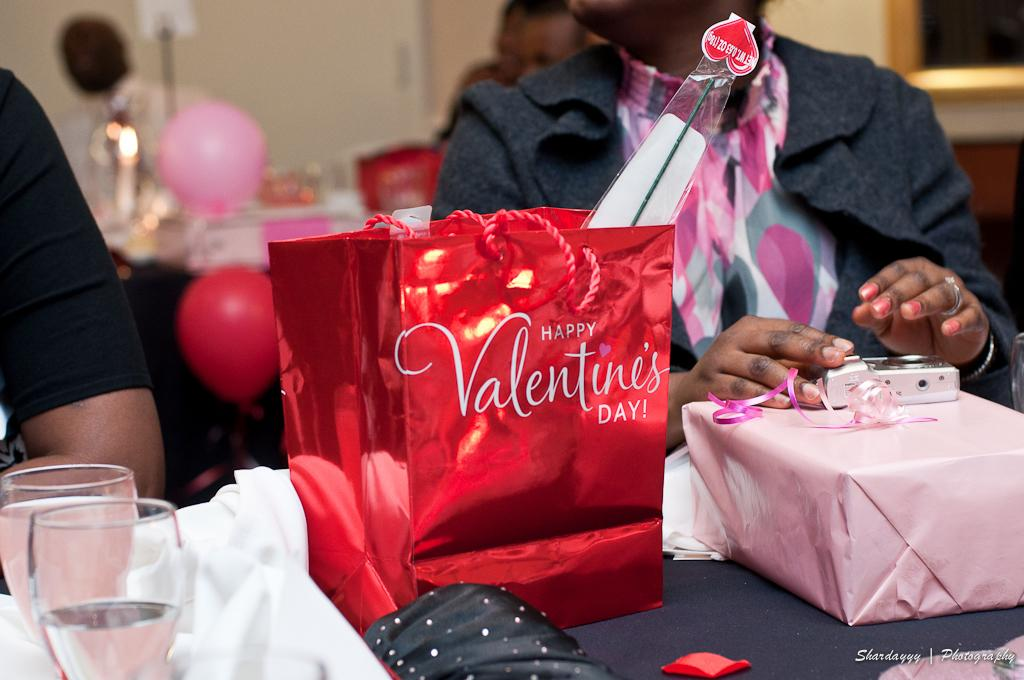What is the person in the image doing? There is a person sitting in the image. What is the person holding in the image? There is a bag in the image. What is the person possibly using to see in the image? There are glasses in the image. What is the person possibly using to cover or protect something in the image? There is cloth in the image. What is on the table in the image? There are objects on the table in the image. What can be seen in the background of the image? There is a person, balloons, and a wall in the background of the image. What is the person in the background of the image doing? There is a person in the background of the image. How many oranges are on the table in the image? There is no mention of oranges in the image; they are not present. What type of blade is being used by the person in the image? There is no blade visible in the image. 